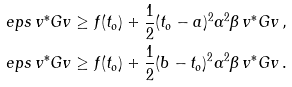Convert formula to latex. <formula><loc_0><loc_0><loc_500><loc_500>\ e p s \, v ^ { * } G v & \geq f ( t _ { o } ) + \frac { 1 } { 2 } ( t _ { o } - a ) ^ { 2 } \alpha ^ { 2 } \beta \, v ^ { * } G v \, , \\ \ e p s \, v ^ { * } G v & \geq f ( t _ { o } ) + \frac { 1 } { 2 } ( b - t _ { o } ) ^ { 2 } \alpha ^ { 2 } \beta \, v ^ { * } G v \, .</formula> 